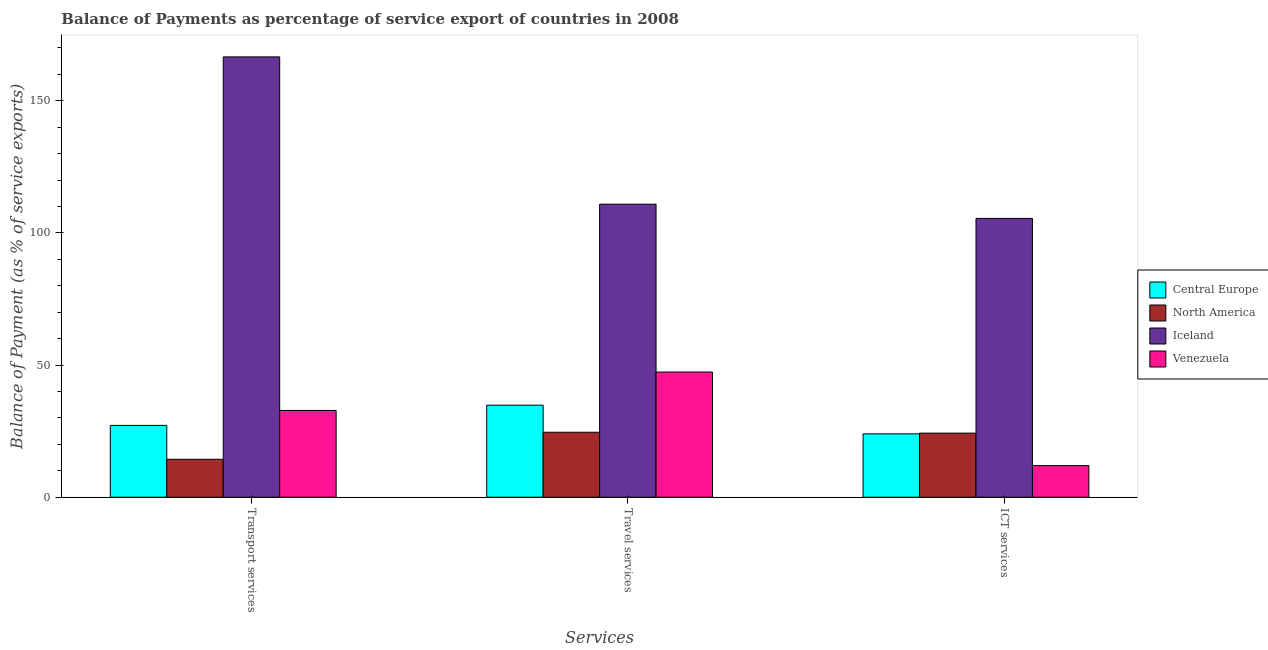Are the number of bars per tick equal to the number of legend labels?
Provide a succinct answer. Yes. Are the number of bars on each tick of the X-axis equal?
Offer a very short reply. Yes. What is the label of the 1st group of bars from the left?
Keep it short and to the point. Transport services. What is the balance of payment of ict services in North America?
Keep it short and to the point. 24.24. Across all countries, what is the maximum balance of payment of transport services?
Keep it short and to the point. 166.58. Across all countries, what is the minimum balance of payment of travel services?
Provide a short and direct response. 24.58. In which country was the balance of payment of travel services minimum?
Your answer should be very brief. North America. What is the total balance of payment of transport services in the graph?
Your answer should be very brief. 240.94. What is the difference between the balance of payment of ict services in Venezuela and that in North America?
Give a very brief answer. -12.29. What is the difference between the balance of payment of travel services in Venezuela and the balance of payment of ict services in Iceland?
Your answer should be compact. -58.12. What is the average balance of payment of travel services per country?
Provide a succinct answer. 54.4. What is the difference between the balance of payment of travel services and balance of payment of ict services in Central Europe?
Your answer should be compact. 10.86. What is the ratio of the balance of payment of travel services in North America to that in Central Europe?
Provide a succinct answer. 0.71. Is the balance of payment of transport services in Central Europe less than that in Venezuela?
Offer a very short reply. Yes. Is the difference between the balance of payment of travel services in North America and Central Europe greater than the difference between the balance of payment of ict services in North America and Central Europe?
Your answer should be very brief. No. What is the difference between the highest and the second highest balance of payment of ict services?
Ensure brevity in your answer.  81.23. What is the difference between the highest and the lowest balance of payment of ict services?
Provide a short and direct response. 93.52. Is the sum of the balance of payment of ict services in Iceland and Central Europe greater than the maximum balance of payment of transport services across all countries?
Your response must be concise. No. What does the 4th bar from the left in ICT services represents?
Ensure brevity in your answer.  Venezuela. What does the 4th bar from the right in Travel services represents?
Give a very brief answer. Central Europe. How many bars are there?
Give a very brief answer. 12. What is the difference between two consecutive major ticks on the Y-axis?
Ensure brevity in your answer.  50. Does the graph contain grids?
Provide a succinct answer. No. Where does the legend appear in the graph?
Your answer should be compact. Center right. How many legend labels are there?
Provide a short and direct response. 4. What is the title of the graph?
Offer a terse response. Balance of Payments as percentage of service export of countries in 2008. Does "Low & middle income" appear as one of the legend labels in the graph?
Offer a very short reply. No. What is the label or title of the X-axis?
Keep it short and to the point. Services. What is the label or title of the Y-axis?
Your answer should be very brief. Balance of Payment (as % of service exports). What is the Balance of Payment (as % of service exports) in Central Europe in Transport services?
Give a very brief answer. 27.18. What is the Balance of Payment (as % of service exports) in North America in Transport services?
Provide a succinct answer. 14.35. What is the Balance of Payment (as % of service exports) in Iceland in Transport services?
Give a very brief answer. 166.58. What is the Balance of Payment (as % of service exports) of Venezuela in Transport services?
Provide a short and direct response. 32.83. What is the Balance of Payment (as % of service exports) of Central Europe in Travel services?
Keep it short and to the point. 34.83. What is the Balance of Payment (as % of service exports) in North America in Travel services?
Make the answer very short. 24.58. What is the Balance of Payment (as % of service exports) of Iceland in Travel services?
Offer a very short reply. 110.86. What is the Balance of Payment (as % of service exports) of Venezuela in Travel services?
Provide a short and direct response. 47.36. What is the Balance of Payment (as % of service exports) of Central Europe in ICT services?
Offer a terse response. 23.97. What is the Balance of Payment (as % of service exports) in North America in ICT services?
Your answer should be compact. 24.24. What is the Balance of Payment (as % of service exports) of Iceland in ICT services?
Keep it short and to the point. 105.47. What is the Balance of Payment (as % of service exports) in Venezuela in ICT services?
Provide a succinct answer. 11.95. Across all Services, what is the maximum Balance of Payment (as % of service exports) in Central Europe?
Make the answer very short. 34.83. Across all Services, what is the maximum Balance of Payment (as % of service exports) of North America?
Offer a terse response. 24.58. Across all Services, what is the maximum Balance of Payment (as % of service exports) of Iceland?
Provide a short and direct response. 166.58. Across all Services, what is the maximum Balance of Payment (as % of service exports) of Venezuela?
Make the answer very short. 47.36. Across all Services, what is the minimum Balance of Payment (as % of service exports) of Central Europe?
Make the answer very short. 23.97. Across all Services, what is the minimum Balance of Payment (as % of service exports) of North America?
Make the answer very short. 14.35. Across all Services, what is the minimum Balance of Payment (as % of service exports) in Iceland?
Provide a short and direct response. 105.47. Across all Services, what is the minimum Balance of Payment (as % of service exports) of Venezuela?
Keep it short and to the point. 11.95. What is the total Balance of Payment (as % of service exports) of Central Europe in the graph?
Provide a short and direct response. 85.97. What is the total Balance of Payment (as % of service exports) of North America in the graph?
Provide a short and direct response. 63.17. What is the total Balance of Payment (as % of service exports) in Iceland in the graph?
Your response must be concise. 382.92. What is the total Balance of Payment (as % of service exports) in Venezuela in the graph?
Give a very brief answer. 92.14. What is the difference between the Balance of Payment (as % of service exports) of Central Europe in Transport services and that in Travel services?
Your answer should be compact. -7.65. What is the difference between the Balance of Payment (as % of service exports) of North America in Transport services and that in Travel services?
Your answer should be very brief. -10.22. What is the difference between the Balance of Payment (as % of service exports) of Iceland in Transport services and that in Travel services?
Provide a short and direct response. 55.72. What is the difference between the Balance of Payment (as % of service exports) of Venezuela in Transport services and that in Travel services?
Give a very brief answer. -14.53. What is the difference between the Balance of Payment (as % of service exports) of Central Europe in Transport services and that in ICT services?
Your response must be concise. 3.21. What is the difference between the Balance of Payment (as % of service exports) in North America in Transport services and that in ICT services?
Offer a terse response. -9.89. What is the difference between the Balance of Payment (as % of service exports) in Iceland in Transport services and that in ICT services?
Your answer should be compact. 61.11. What is the difference between the Balance of Payment (as % of service exports) in Venezuela in Transport services and that in ICT services?
Keep it short and to the point. 20.87. What is the difference between the Balance of Payment (as % of service exports) in Central Europe in Travel services and that in ICT services?
Your answer should be very brief. 10.86. What is the difference between the Balance of Payment (as % of service exports) in North America in Travel services and that in ICT services?
Your response must be concise. 0.33. What is the difference between the Balance of Payment (as % of service exports) of Iceland in Travel services and that in ICT services?
Offer a very short reply. 5.39. What is the difference between the Balance of Payment (as % of service exports) in Venezuela in Travel services and that in ICT services?
Offer a very short reply. 35.4. What is the difference between the Balance of Payment (as % of service exports) in Central Europe in Transport services and the Balance of Payment (as % of service exports) in North America in Travel services?
Keep it short and to the point. 2.6. What is the difference between the Balance of Payment (as % of service exports) in Central Europe in Transport services and the Balance of Payment (as % of service exports) in Iceland in Travel services?
Offer a terse response. -83.68. What is the difference between the Balance of Payment (as % of service exports) of Central Europe in Transport services and the Balance of Payment (as % of service exports) of Venezuela in Travel services?
Provide a succinct answer. -20.18. What is the difference between the Balance of Payment (as % of service exports) of North America in Transport services and the Balance of Payment (as % of service exports) of Iceland in Travel services?
Provide a short and direct response. -96.51. What is the difference between the Balance of Payment (as % of service exports) of North America in Transport services and the Balance of Payment (as % of service exports) of Venezuela in Travel services?
Give a very brief answer. -33. What is the difference between the Balance of Payment (as % of service exports) of Iceland in Transport services and the Balance of Payment (as % of service exports) of Venezuela in Travel services?
Keep it short and to the point. 119.23. What is the difference between the Balance of Payment (as % of service exports) of Central Europe in Transport services and the Balance of Payment (as % of service exports) of North America in ICT services?
Provide a succinct answer. 2.94. What is the difference between the Balance of Payment (as % of service exports) in Central Europe in Transport services and the Balance of Payment (as % of service exports) in Iceland in ICT services?
Your response must be concise. -78.3. What is the difference between the Balance of Payment (as % of service exports) in Central Europe in Transport services and the Balance of Payment (as % of service exports) in Venezuela in ICT services?
Give a very brief answer. 15.22. What is the difference between the Balance of Payment (as % of service exports) of North America in Transport services and the Balance of Payment (as % of service exports) of Iceland in ICT services?
Your answer should be compact. -91.12. What is the difference between the Balance of Payment (as % of service exports) in North America in Transport services and the Balance of Payment (as % of service exports) in Venezuela in ICT services?
Provide a succinct answer. 2.4. What is the difference between the Balance of Payment (as % of service exports) of Iceland in Transport services and the Balance of Payment (as % of service exports) of Venezuela in ICT services?
Provide a succinct answer. 154.63. What is the difference between the Balance of Payment (as % of service exports) of Central Europe in Travel services and the Balance of Payment (as % of service exports) of North America in ICT services?
Provide a succinct answer. 10.58. What is the difference between the Balance of Payment (as % of service exports) of Central Europe in Travel services and the Balance of Payment (as % of service exports) of Iceland in ICT services?
Ensure brevity in your answer.  -70.65. What is the difference between the Balance of Payment (as % of service exports) in Central Europe in Travel services and the Balance of Payment (as % of service exports) in Venezuela in ICT services?
Your response must be concise. 22.87. What is the difference between the Balance of Payment (as % of service exports) of North America in Travel services and the Balance of Payment (as % of service exports) of Iceland in ICT services?
Keep it short and to the point. -80.9. What is the difference between the Balance of Payment (as % of service exports) of North America in Travel services and the Balance of Payment (as % of service exports) of Venezuela in ICT services?
Offer a very short reply. 12.62. What is the difference between the Balance of Payment (as % of service exports) of Iceland in Travel services and the Balance of Payment (as % of service exports) of Venezuela in ICT services?
Your answer should be very brief. 98.91. What is the average Balance of Payment (as % of service exports) in Central Europe per Services?
Give a very brief answer. 28.66. What is the average Balance of Payment (as % of service exports) of North America per Services?
Ensure brevity in your answer.  21.06. What is the average Balance of Payment (as % of service exports) in Iceland per Services?
Provide a short and direct response. 127.64. What is the average Balance of Payment (as % of service exports) in Venezuela per Services?
Offer a terse response. 30.71. What is the difference between the Balance of Payment (as % of service exports) in Central Europe and Balance of Payment (as % of service exports) in North America in Transport services?
Offer a terse response. 12.82. What is the difference between the Balance of Payment (as % of service exports) in Central Europe and Balance of Payment (as % of service exports) in Iceland in Transport services?
Your answer should be compact. -139.4. What is the difference between the Balance of Payment (as % of service exports) of Central Europe and Balance of Payment (as % of service exports) of Venezuela in Transport services?
Offer a very short reply. -5.65. What is the difference between the Balance of Payment (as % of service exports) in North America and Balance of Payment (as % of service exports) in Iceland in Transport services?
Keep it short and to the point. -152.23. What is the difference between the Balance of Payment (as % of service exports) in North America and Balance of Payment (as % of service exports) in Venezuela in Transport services?
Provide a succinct answer. -18.47. What is the difference between the Balance of Payment (as % of service exports) in Iceland and Balance of Payment (as % of service exports) in Venezuela in Transport services?
Your response must be concise. 133.75. What is the difference between the Balance of Payment (as % of service exports) of Central Europe and Balance of Payment (as % of service exports) of North America in Travel services?
Provide a succinct answer. 10.25. What is the difference between the Balance of Payment (as % of service exports) in Central Europe and Balance of Payment (as % of service exports) in Iceland in Travel services?
Your response must be concise. -76.03. What is the difference between the Balance of Payment (as % of service exports) of Central Europe and Balance of Payment (as % of service exports) of Venezuela in Travel services?
Offer a very short reply. -12.53. What is the difference between the Balance of Payment (as % of service exports) of North America and Balance of Payment (as % of service exports) of Iceland in Travel services?
Give a very brief answer. -86.28. What is the difference between the Balance of Payment (as % of service exports) of North America and Balance of Payment (as % of service exports) of Venezuela in Travel services?
Your answer should be very brief. -22.78. What is the difference between the Balance of Payment (as % of service exports) of Iceland and Balance of Payment (as % of service exports) of Venezuela in Travel services?
Your answer should be compact. 63.5. What is the difference between the Balance of Payment (as % of service exports) of Central Europe and Balance of Payment (as % of service exports) of North America in ICT services?
Provide a succinct answer. -0.28. What is the difference between the Balance of Payment (as % of service exports) in Central Europe and Balance of Payment (as % of service exports) in Iceland in ICT services?
Your response must be concise. -81.51. What is the difference between the Balance of Payment (as % of service exports) in Central Europe and Balance of Payment (as % of service exports) in Venezuela in ICT services?
Ensure brevity in your answer.  12.01. What is the difference between the Balance of Payment (as % of service exports) in North America and Balance of Payment (as % of service exports) in Iceland in ICT services?
Keep it short and to the point. -81.23. What is the difference between the Balance of Payment (as % of service exports) of North America and Balance of Payment (as % of service exports) of Venezuela in ICT services?
Provide a short and direct response. 12.29. What is the difference between the Balance of Payment (as % of service exports) of Iceland and Balance of Payment (as % of service exports) of Venezuela in ICT services?
Provide a short and direct response. 93.52. What is the ratio of the Balance of Payment (as % of service exports) of Central Europe in Transport services to that in Travel services?
Offer a very short reply. 0.78. What is the ratio of the Balance of Payment (as % of service exports) of North America in Transport services to that in Travel services?
Offer a very short reply. 0.58. What is the ratio of the Balance of Payment (as % of service exports) in Iceland in Transport services to that in Travel services?
Your answer should be very brief. 1.5. What is the ratio of the Balance of Payment (as % of service exports) in Venezuela in Transport services to that in Travel services?
Provide a succinct answer. 0.69. What is the ratio of the Balance of Payment (as % of service exports) in Central Europe in Transport services to that in ICT services?
Give a very brief answer. 1.13. What is the ratio of the Balance of Payment (as % of service exports) of North America in Transport services to that in ICT services?
Your response must be concise. 0.59. What is the ratio of the Balance of Payment (as % of service exports) in Iceland in Transport services to that in ICT services?
Ensure brevity in your answer.  1.58. What is the ratio of the Balance of Payment (as % of service exports) in Venezuela in Transport services to that in ICT services?
Provide a short and direct response. 2.75. What is the ratio of the Balance of Payment (as % of service exports) in Central Europe in Travel services to that in ICT services?
Provide a short and direct response. 1.45. What is the ratio of the Balance of Payment (as % of service exports) in North America in Travel services to that in ICT services?
Your answer should be compact. 1.01. What is the ratio of the Balance of Payment (as % of service exports) in Iceland in Travel services to that in ICT services?
Your answer should be compact. 1.05. What is the ratio of the Balance of Payment (as % of service exports) of Venezuela in Travel services to that in ICT services?
Offer a very short reply. 3.96. What is the difference between the highest and the second highest Balance of Payment (as % of service exports) in Central Europe?
Offer a very short reply. 7.65. What is the difference between the highest and the second highest Balance of Payment (as % of service exports) in North America?
Your answer should be very brief. 0.33. What is the difference between the highest and the second highest Balance of Payment (as % of service exports) of Iceland?
Keep it short and to the point. 55.72. What is the difference between the highest and the second highest Balance of Payment (as % of service exports) of Venezuela?
Provide a short and direct response. 14.53. What is the difference between the highest and the lowest Balance of Payment (as % of service exports) of Central Europe?
Ensure brevity in your answer.  10.86. What is the difference between the highest and the lowest Balance of Payment (as % of service exports) of North America?
Keep it short and to the point. 10.22. What is the difference between the highest and the lowest Balance of Payment (as % of service exports) in Iceland?
Your answer should be very brief. 61.11. What is the difference between the highest and the lowest Balance of Payment (as % of service exports) of Venezuela?
Keep it short and to the point. 35.4. 